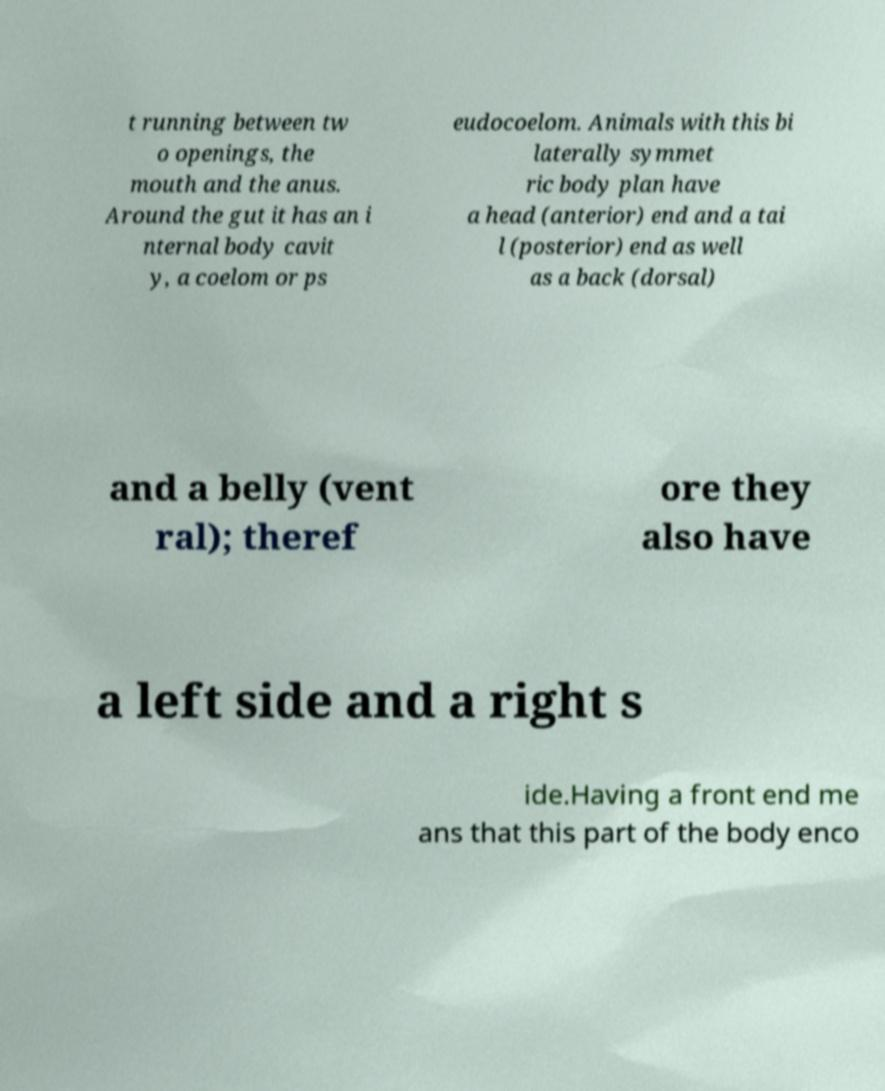For documentation purposes, I need the text within this image transcribed. Could you provide that? t running between tw o openings, the mouth and the anus. Around the gut it has an i nternal body cavit y, a coelom or ps eudocoelom. Animals with this bi laterally symmet ric body plan have a head (anterior) end and a tai l (posterior) end as well as a back (dorsal) and a belly (vent ral); theref ore they also have a left side and a right s ide.Having a front end me ans that this part of the body enco 